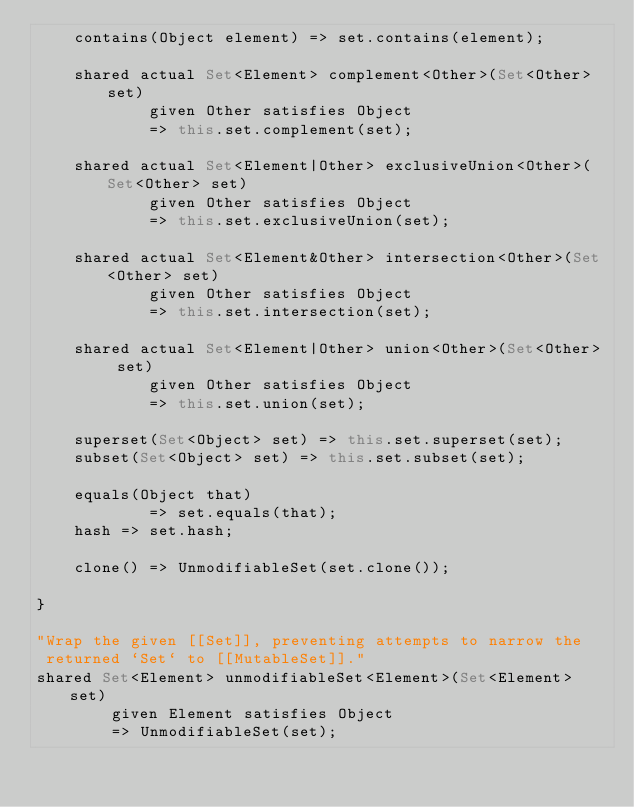<code> <loc_0><loc_0><loc_500><loc_500><_Ceylon_>    contains(Object element) => set.contains(element);
    
    shared actual Set<Element> complement<Other>(Set<Other> set)
            given Other satisfies Object 
            => this.set.complement(set);
    
    shared actual Set<Element|Other> exclusiveUnion<Other>(Set<Other> set)
            given Other satisfies Object 
            => this.set.exclusiveUnion(set);
    
    shared actual Set<Element&Other> intersection<Other>(Set<Other> set)
            given Other satisfies Object 
            => this.set.intersection(set);
    
    shared actual Set<Element|Other> union<Other>(Set<Other> set)
            given Other satisfies Object 
            => this.set.union(set);
    
    superset(Set<Object> set) => this.set.superset(set);
    subset(Set<Object> set) => this.set.subset(set);
    
    equals(Object that) 
            => set.equals(that);
    hash => set.hash;
    
    clone() => UnmodifiableSet(set.clone());
    
}

"Wrap the given [[Set]], preventing attempts to narrow the
 returned `Set` to [[MutableSet]]."
shared Set<Element> unmodifiableSet<Element>(Set<Element> set)
        given Element satisfies Object
        => UnmodifiableSet(set);
</code> 